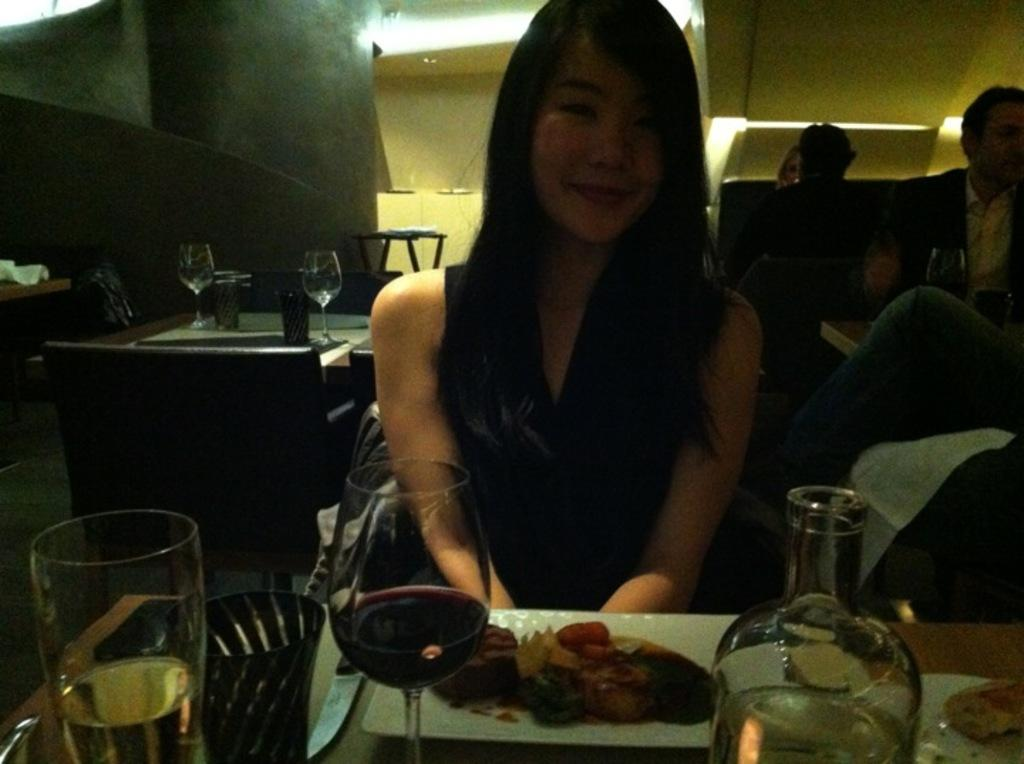What object is located in the bottom left corner of the image? There is a glass in the bottom left corner of the image. What can be seen in the center of the image? A girl is sitting in the middle of the image. What type of garden can be seen in the image? There is no garden present in the image; it only features a glass in the bottom left corner and a girl sitting in the middle. 